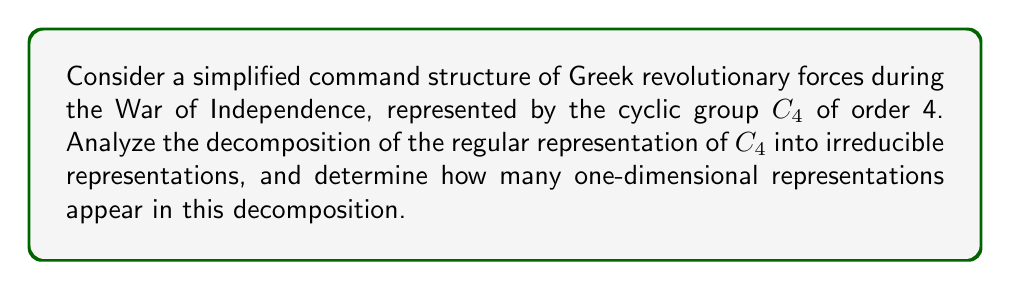Could you help me with this problem? Let's approach this step-by-step:

1) The regular representation of a finite group $G$ has dimension $|G|$, where $|G|$ is the order of the group. In this case, $|C_4| = 4$.

2) For cyclic groups, all irreducible representations are one-dimensional. The number of distinct irreducible representations is equal to the number of conjugacy classes, which for $C_4$ is 4.

3) Let's denote the generator of $C_4$ as $g$. The four irreducible representations are:

   $\chi_0(g^k) = 1$ for all $k$
   $\chi_1(g^k) = i^k$
   $\chi_2(g^k) = (-1)^k$
   $\chi_3(g^k) = (-i)^k$

4) The regular representation $R$ decomposes as a direct sum of all irreducible representations, each appearing with multiplicity equal to its dimension:

   $R = m_0\chi_0 \oplus m_1\chi_1 \oplus m_2\chi_2 \oplus m_3\chi_3$

5) For any finite group, the multiplicity of each irreducible representation in the regular representation is equal to its dimension. In this case, all irreducible representations are one-dimensional, so:

   $m_0 = m_1 = m_2 = m_3 = 1$

6) Therefore, the regular representation decomposes as:

   $R = \chi_0 \oplus \chi_1 \oplus \chi_2 \oplus \chi_3$

7) Count the number of one-dimensional representations in this decomposition: there are 4.
Answer: 4 